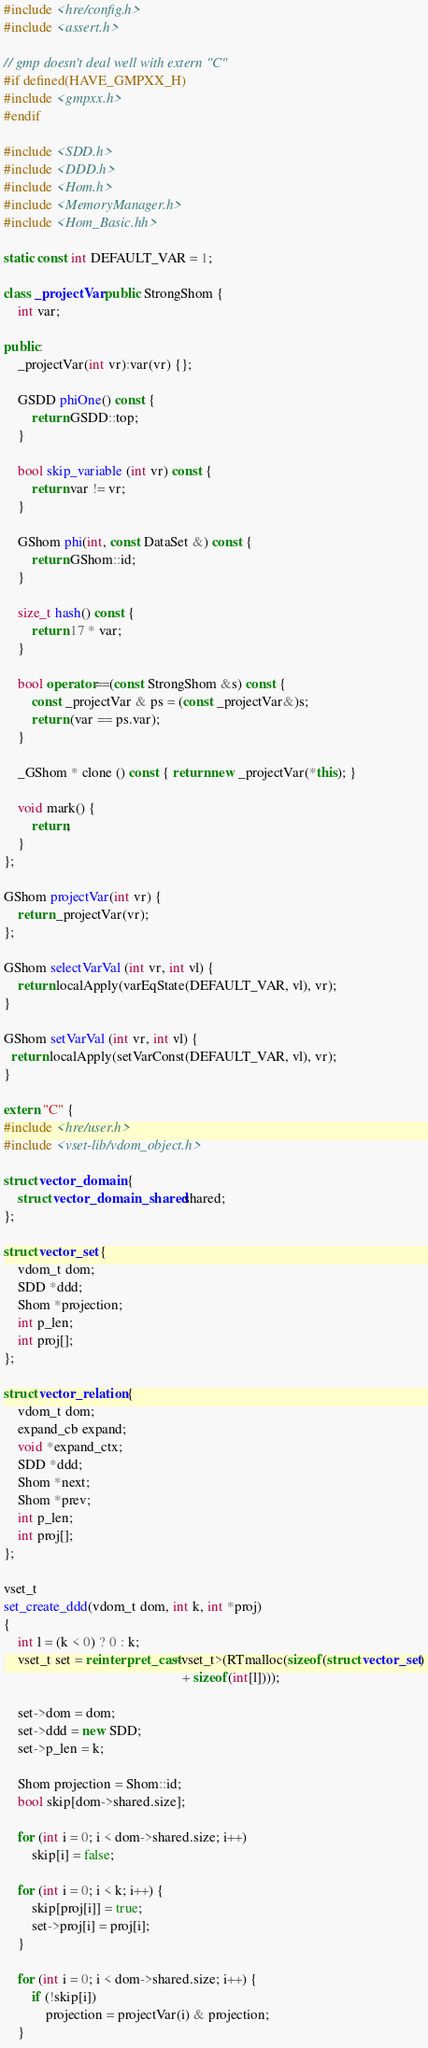<code> <loc_0><loc_0><loc_500><loc_500><_C++_>#include <hre/config.h>
#include <assert.h>

// gmp doesn't deal well with extern "C"
#if defined(HAVE_GMPXX_H)
#include <gmpxx.h>
#endif

#include <SDD.h>
#include <DDD.h>
#include <Hom.h>
#include <MemoryManager.h>
#include <Hom_Basic.hh>

static const int DEFAULT_VAR = 1;

class _projectVar:public StrongShom {
    int var;

public:
    _projectVar(int vr):var(vr) {};

    GSDD phiOne() const {
        return GSDD::top;
    }

    bool skip_variable (int vr) const {
        return var != vr;
    }

    GShom phi(int, const DataSet &) const {
        return GShom::id;
    }

    size_t hash() const {
        return 17 * var;
    }

    bool operator==(const StrongShom &s) const {
        const _projectVar & ps = (const _projectVar&)s;
        return (var == ps.var);
    }

    _GShom * clone () const { return new _projectVar(*this); }

    void mark() {
        return;
    }
};

GShom projectVar(int vr) {
    return _projectVar(vr);
};

GShom selectVarVal (int vr, int vl) {
    return localApply(varEqState(DEFAULT_VAR, vl), vr);
}

GShom setVarVal (int vr, int vl) {
  return localApply(setVarConst(DEFAULT_VAR, vl), vr);
}

extern "C" {
#include <hre/user.h>
#include <vset-lib/vdom_object.h>

struct vector_domain {
    struct vector_domain_shared shared;
};

struct vector_set {
    vdom_t dom;
    SDD *ddd;
    Shom *projection;
    int p_len;
    int proj[];
};

struct vector_relation {
    vdom_t dom;
    expand_cb expand;
    void *expand_ctx;
    SDD *ddd;
    Shom *next;
    Shom *prev;
    int p_len;
    int proj[];
};

vset_t
set_create_ddd(vdom_t dom, int k, int *proj)
{
    int l = (k < 0) ? 0 : k;
    vset_t set = reinterpret_cast<vset_t>(RTmalloc(sizeof(struct vector_set)
                                                   + sizeof(int[l])));

    set->dom = dom;
    set->ddd = new SDD;
    set->p_len = k;

    Shom projection = Shom::id;
    bool skip[dom->shared.size];

    for (int i = 0; i < dom->shared.size; i++)
        skip[i] = false;

    for (int i = 0; i < k; i++) {
        skip[proj[i]] = true;
        set->proj[i] = proj[i];
    }

    for (int i = 0; i < dom->shared.size; i++) {
        if (!skip[i])
            projection = projectVar(i) & projection;
    }
</code> 